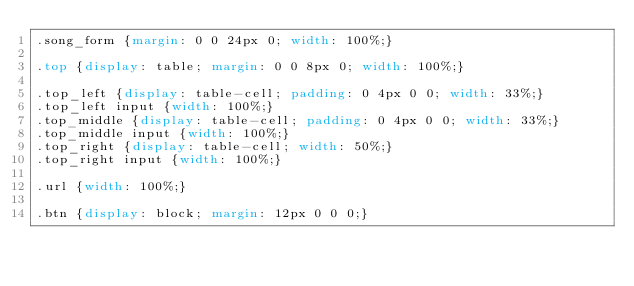Convert code to text. <code><loc_0><loc_0><loc_500><loc_500><_CSS_>.song_form {margin: 0 0 24px 0; width: 100%;}

.top {display: table; margin: 0 0 8px 0; width: 100%;}

.top_left {display: table-cell; padding: 0 4px 0 0; width: 33%;}
.top_left input {width: 100%;}
.top_middle {display: table-cell; padding: 0 4px 0 0; width: 33%;}
.top_middle input {width: 100%;}
.top_right {display: table-cell; width: 50%;}
.top_right input {width: 100%;}

.url {width: 100%;}

.btn {display: block; margin: 12px 0 0 0;}</code> 